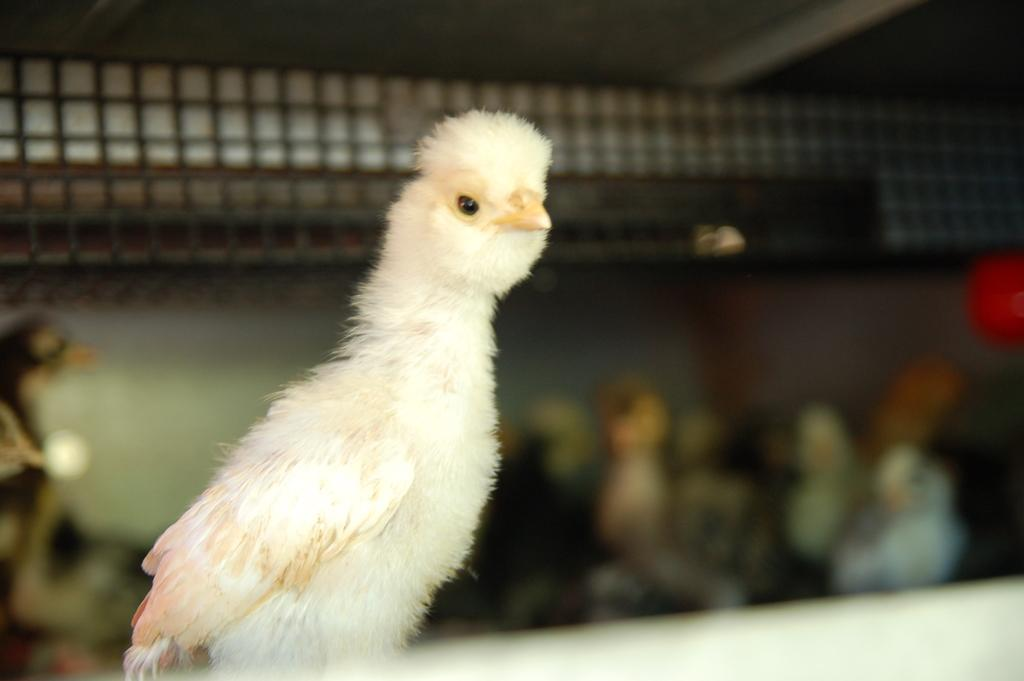What type of animal can be seen in the picture? There is a bird in the picture. Can you describe the setting of the picture? There are people in the background of the picture. What type of waste is being disposed of by the bird in the picture? There is no waste present in the image, and the bird is not disposing of anything. 